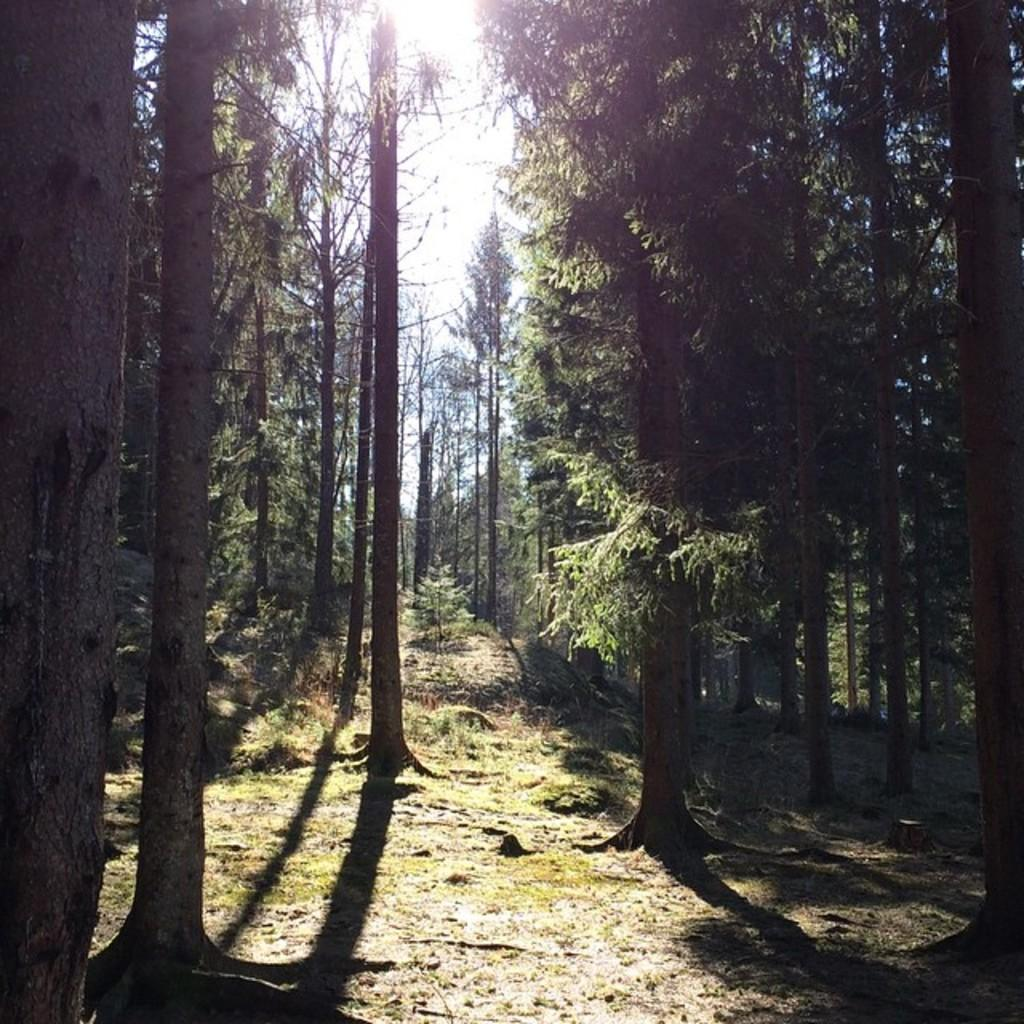What type of vegetation can be seen in the image? There are trees and grass in the image. What part of the natural environment is visible in the image? The sky is visible in the background of the image. What type of wound can be seen on the stem of the tree in the image? There is no wound visible on the stem of a tree in the image, as there is no tree with a stem present. 